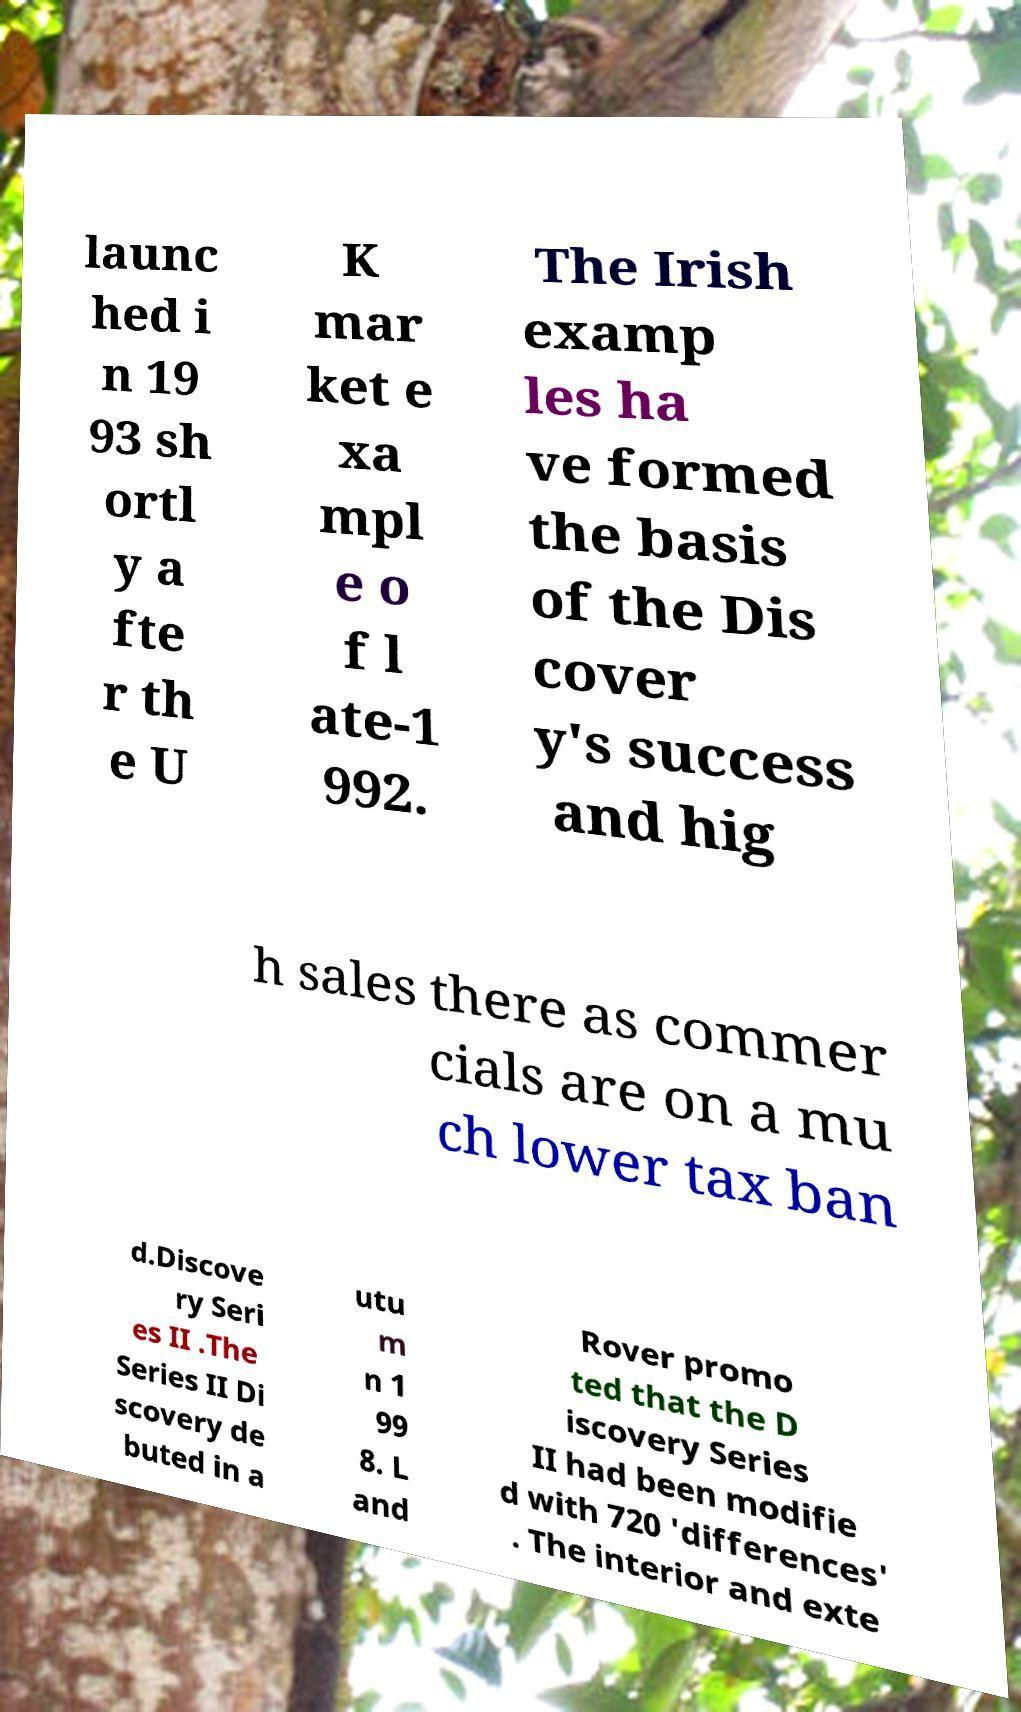Could you assist in decoding the text presented in this image and type it out clearly? launc hed i n 19 93 sh ortl y a fte r th e U K mar ket e xa mpl e o f l ate-1 992. The Irish examp les ha ve formed the basis of the Dis cover y's success and hig h sales there as commer cials are on a mu ch lower tax ban d.Discove ry Seri es II .The Series II Di scovery de buted in a utu m n 1 99 8. L and Rover promo ted that the D iscovery Series II had been modifie d with 720 'differences' . The interior and exte 